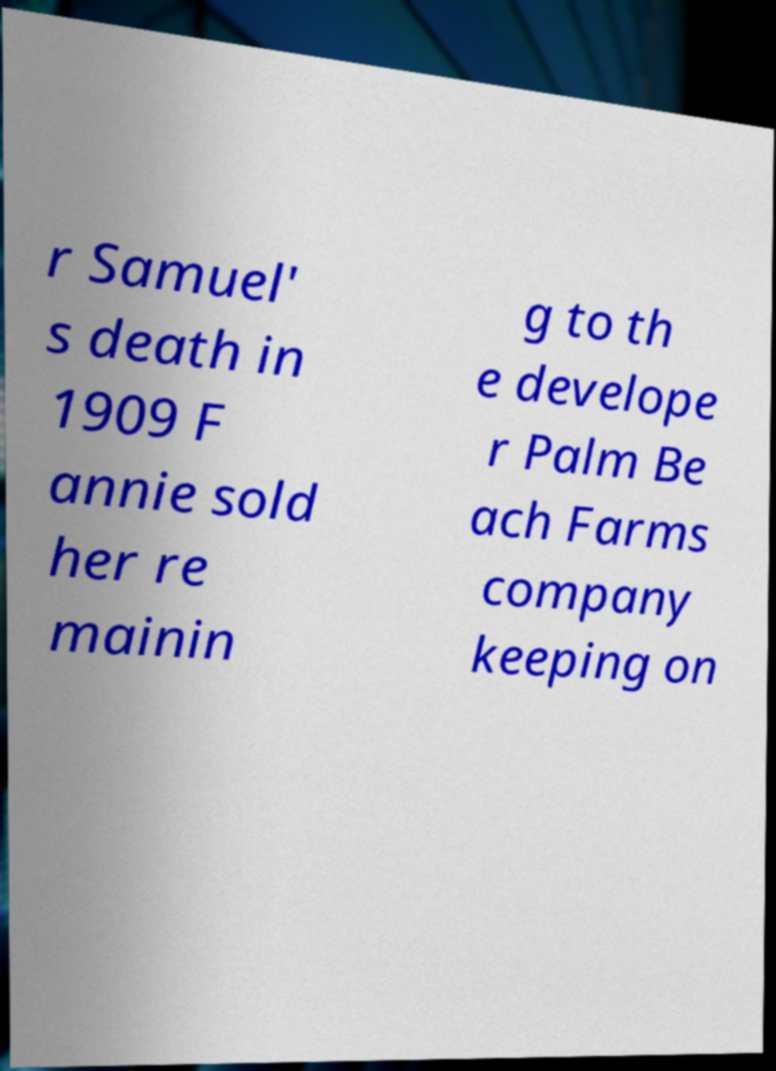Could you extract and type out the text from this image? r Samuel' s death in 1909 F annie sold her re mainin g to th e develope r Palm Be ach Farms company keeping on 